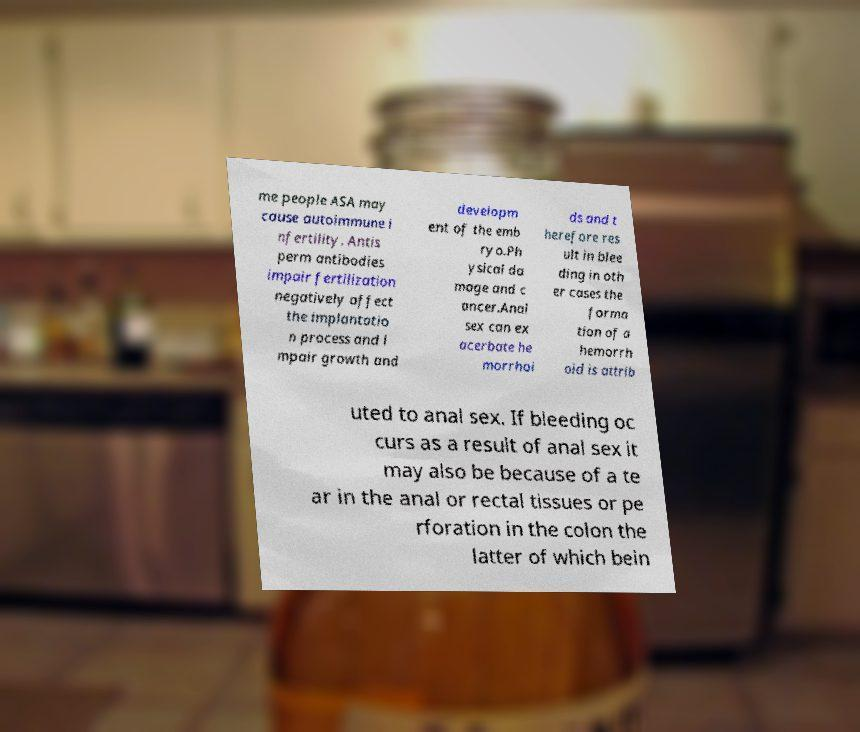There's text embedded in this image that I need extracted. Can you transcribe it verbatim? me people ASA may cause autoimmune i nfertility. Antis perm antibodies impair fertilization negatively affect the implantatio n process and i mpair growth and developm ent of the emb ryo.Ph ysical da mage and c ancer.Anal sex can ex acerbate he morrhoi ds and t herefore res ult in blee ding in oth er cases the forma tion of a hemorrh oid is attrib uted to anal sex. If bleeding oc curs as a result of anal sex it may also be because of a te ar in the anal or rectal tissues or pe rforation in the colon the latter of which bein 